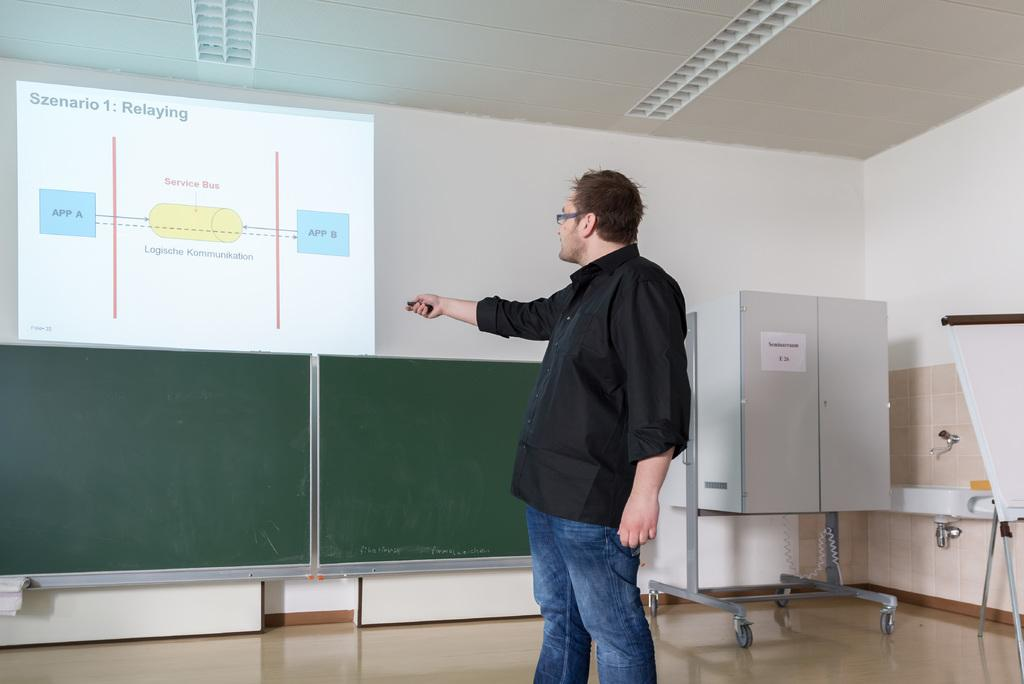Provide a one-sentence caption for the provided image. A man is showing a powerpoint presentation about Relaying. 